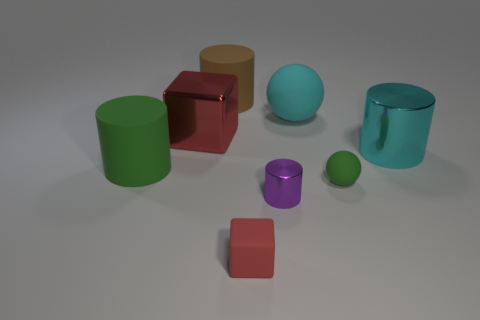Are there any big shiny cylinders of the same color as the big sphere?
Offer a terse response. Yes. What is the size of the object that is the same color as the shiny block?
Ensure brevity in your answer.  Small. What is the size of the red rubber cube?
Your answer should be compact. Small. What number of things are big cyan matte spheres or green balls?
Your answer should be very brief. 2. There is a rubber cylinder behind the big green rubber object; what size is it?
Give a very brief answer. Large. There is a large thing that is behind the big cyan cylinder and in front of the big cyan rubber thing; what color is it?
Offer a terse response. Red. Is the large cylinder that is to the right of the large brown cylinder made of the same material as the small red block?
Give a very brief answer. No. Do the tiny block and the block that is behind the large green thing have the same color?
Ensure brevity in your answer.  Yes. Are there any tiny red cubes in front of the brown thing?
Your response must be concise. Yes. Does the red cube that is on the left side of the tiny matte cube have the same size as the matte thing that is on the left side of the brown thing?
Make the answer very short. Yes. 